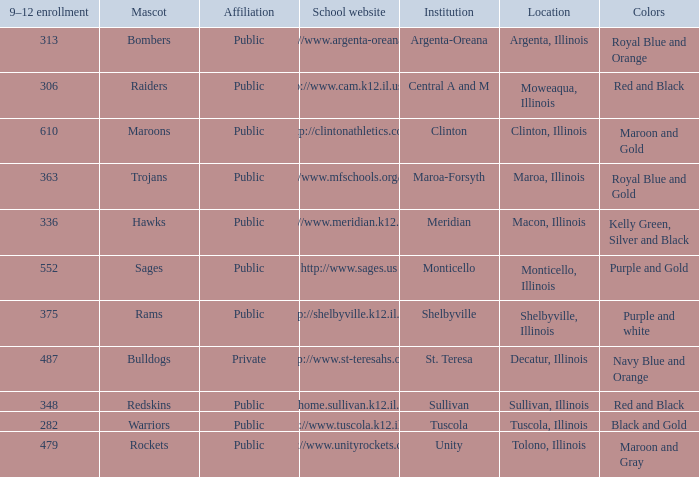What colors can you see players from Tolono, Illinois wearing? Maroon and Gray. 